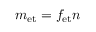Convert formula to latex. <formula><loc_0><loc_0><loc_500><loc_500>m _ { e t } = f _ { e t } n</formula> 